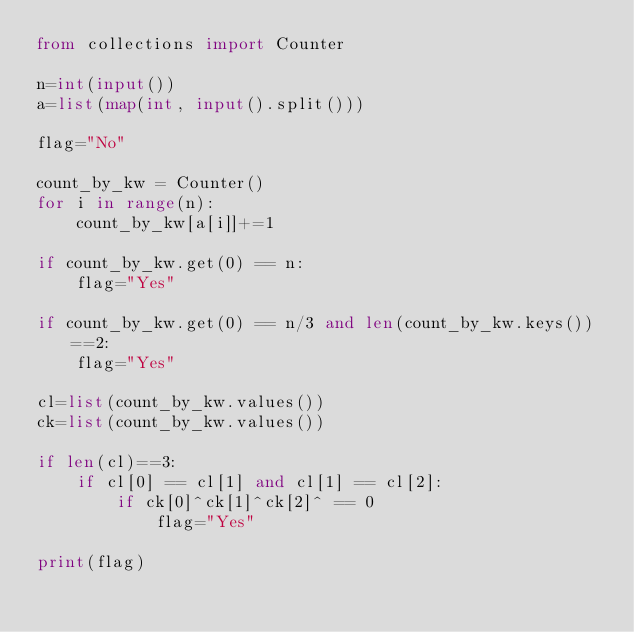<code> <loc_0><loc_0><loc_500><loc_500><_Python_>from collections import Counter

n=int(input())
a=list(map(int, input().split()))

flag="No"

count_by_kw = Counter()
for i in range(n):
    count_by_kw[a[i]]+=1

if count_by_kw.get(0) == n:
    flag="Yes"

if count_by_kw.get(0) == n/3 and len(count_by_kw.keys())==2:
    flag="Yes"

cl=list(count_by_kw.values())
ck=list(count_by_kw.values())

if len(cl)==3:
    if cl[0] == cl[1] and cl[1] == cl[2]:
        if ck[0]^ck[1]^ck[2]^ == 0
            flag="Yes"
        
print(flag)



</code> 